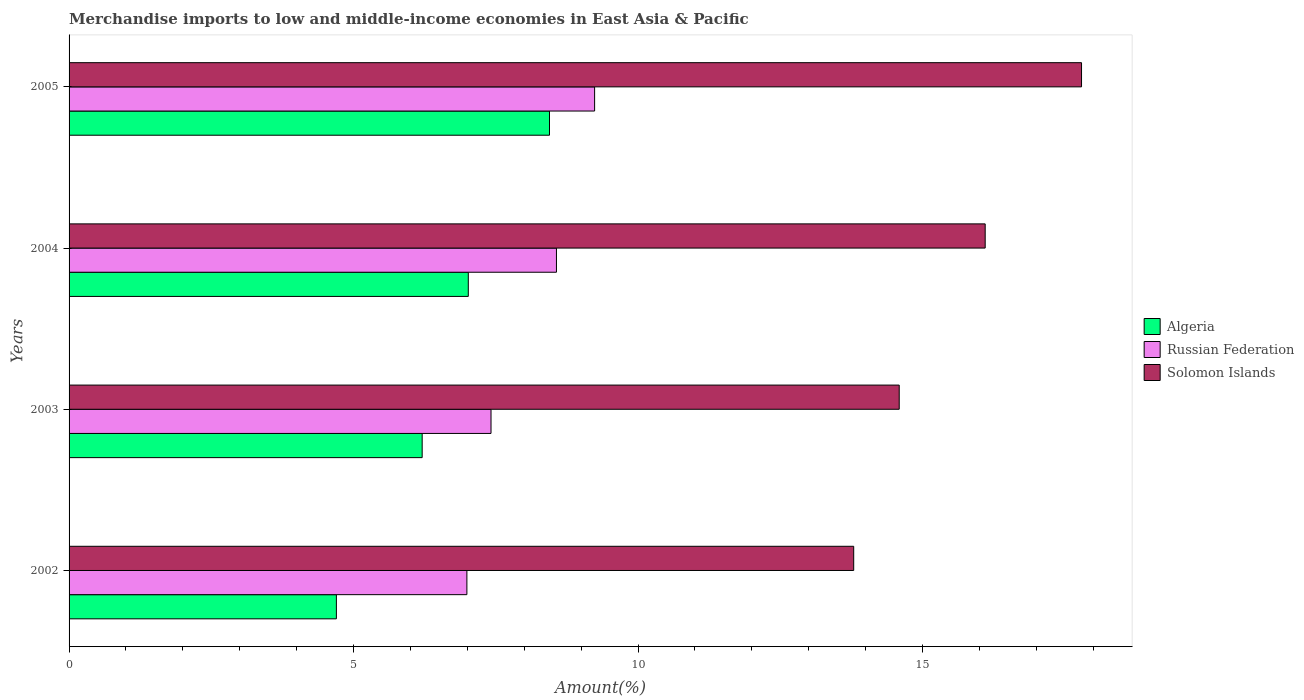Are the number of bars on each tick of the Y-axis equal?
Your answer should be very brief. Yes. How many bars are there on the 2nd tick from the top?
Your answer should be very brief. 3. What is the label of the 1st group of bars from the top?
Your answer should be compact. 2005. What is the percentage of amount earned from merchandise imports in Algeria in 2002?
Your answer should be very brief. 4.7. Across all years, what is the maximum percentage of amount earned from merchandise imports in Solomon Islands?
Your answer should be compact. 17.79. Across all years, what is the minimum percentage of amount earned from merchandise imports in Solomon Islands?
Keep it short and to the point. 13.79. In which year was the percentage of amount earned from merchandise imports in Russian Federation maximum?
Your answer should be compact. 2005. In which year was the percentage of amount earned from merchandise imports in Russian Federation minimum?
Your answer should be very brief. 2002. What is the total percentage of amount earned from merchandise imports in Algeria in the graph?
Provide a succinct answer. 26.36. What is the difference between the percentage of amount earned from merchandise imports in Russian Federation in 2003 and that in 2004?
Your answer should be very brief. -1.15. What is the difference between the percentage of amount earned from merchandise imports in Russian Federation in 2004 and the percentage of amount earned from merchandise imports in Solomon Islands in 2003?
Offer a very short reply. -6.02. What is the average percentage of amount earned from merchandise imports in Algeria per year?
Keep it short and to the point. 6.59. In the year 2003, what is the difference between the percentage of amount earned from merchandise imports in Solomon Islands and percentage of amount earned from merchandise imports in Russian Federation?
Offer a very short reply. 7.17. In how many years, is the percentage of amount earned from merchandise imports in Algeria greater than 8 %?
Keep it short and to the point. 1. What is the ratio of the percentage of amount earned from merchandise imports in Russian Federation in 2002 to that in 2005?
Ensure brevity in your answer.  0.76. What is the difference between the highest and the second highest percentage of amount earned from merchandise imports in Russian Federation?
Keep it short and to the point. 0.67. What is the difference between the highest and the lowest percentage of amount earned from merchandise imports in Algeria?
Ensure brevity in your answer.  3.75. In how many years, is the percentage of amount earned from merchandise imports in Algeria greater than the average percentage of amount earned from merchandise imports in Algeria taken over all years?
Make the answer very short. 2. What does the 3rd bar from the top in 2002 represents?
Your answer should be compact. Algeria. What does the 1st bar from the bottom in 2005 represents?
Your answer should be very brief. Algeria. Is it the case that in every year, the sum of the percentage of amount earned from merchandise imports in Solomon Islands and percentage of amount earned from merchandise imports in Russian Federation is greater than the percentage of amount earned from merchandise imports in Algeria?
Offer a very short reply. Yes. How many bars are there?
Your response must be concise. 12. Are all the bars in the graph horizontal?
Your answer should be very brief. Yes. What is the difference between two consecutive major ticks on the X-axis?
Your response must be concise. 5. Are the values on the major ticks of X-axis written in scientific E-notation?
Your answer should be compact. No. Does the graph contain any zero values?
Provide a short and direct response. No. How are the legend labels stacked?
Your answer should be compact. Vertical. What is the title of the graph?
Your answer should be very brief. Merchandise imports to low and middle-income economies in East Asia & Pacific. What is the label or title of the X-axis?
Your answer should be very brief. Amount(%). What is the Amount(%) of Algeria in 2002?
Your answer should be very brief. 4.7. What is the Amount(%) of Russian Federation in 2002?
Give a very brief answer. 6.99. What is the Amount(%) in Solomon Islands in 2002?
Your answer should be very brief. 13.79. What is the Amount(%) of Algeria in 2003?
Keep it short and to the point. 6.21. What is the Amount(%) of Russian Federation in 2003?
Your response must be concise. 7.42. What is the Amount(%) in Solomon Islands in 2003?
Provide a succinct answer. 14.59. What is the Amount(%) of Algeria in 2004?
Your answer should be compact. 7.02. What is the Amount(%) in Russian Federation in 2004?
Ensure brevity in your answer.  8.57. What is the Amount(%) in Solomon Islands in 2004?
Provide a short and direct response. 16.1. What is the Amount(%) of Algeria in 2005?
Your answer should be compact. 8.44. What is the Amount(%) of Russian Federation in 2005?
Your answer should be compact. 9.24. What is the Amount(%) of Solomon Islands in 2005?
Provide a short and direct response. 17.79. Across all years, what is the maximum Amount(%) of Algeria?
Your answer should be compact. 8.44. Across all years, what is the maximum Amount(%) of Russian Federation?
Offer a terse response. 9.24. Across all years, what is the maximum Amount(%) of Solomon Islands?
Give a very brief answer. 17.79. Across all years, what is the minimum Amount(%) in Algeria?
Ensure brevity in your answer.  4.7. Across all years, what is the minimum Amount(%) of Russian Federation?
Make the answer very short. 6.99. Across all years, what is the minimum Amount(%) of Solomon Islands?
Keep it short and to the point. 13.79. What is the total Amount(%) in Algeria in the graph?
Ensure brevity in your answer.  26.36. What is the total Amount(%) in Russian Federation in the graph?
Ensure brevity in your answer.  32.21. What is the total Amount(%) of Solomon Islands in the graph?
Your response must be concise. 62.28. What is the difference between the Amount(%) in Algeria in 2002 and that in 2003?
Provide a succinct answer. -1.51. What is the difference between the Amount(%) in Russian Federation in 2002 and that in 2003?
Provide a succinct answer. -0.42. What is the difference between the Amount(%) in Solomon Islands in 2002 and that in 2003?
Give a very brief answer. -0.8. What is the difference between the Amount(%) in Algeria in 2002 and that in 2004?
Your response must be concise. -2.32. What is the difference between the Amount(%) in Russian Federation in 2002 and that in 2004?
Make the answer very short. -1.57. What is the difference between the Amount(%) of Solomon Islands in 2002 and that in 2004?
Provide a succinct answer. -2.31. What is the difference between the Amount(%) in Algeria in 2002 and that in 2005?
Your response must be concise. -3.75. What is the difference between the Amount(%) in Russian Federation in 2002 and that in 2005?
Make the answer very short. -2.24. What is the difference between the Amount(%) of Solomon Islands in 2002 and that in 2005?
Provide a short and direct response. -4. What is the difference between the Amount(%) of Algeria in 2003 and that in 2004?
Your answer should be compact. -0.81. What is the difference between the Amount(%) in Russian Federation in 2003 and that in 2004?
Your response must be concise. -1.15. What is the difference between the Amount(%) of Solomon Islands in 2003 and that in 2004?
Your answer should be very brief. -1.51. What is the difference between the Amount(%) of Algeria in 2003 and that in 2005?
Ensure brevity in your answer.  -2.24. What is the difference between the Amount(%) of Russian Federation in 2003 and that in 2005?
Ensure brevity in your answer.  -1.82. What is the difference between the Amount(%) of Solomon Islands in 2003 and that in 2005?
Make the answer very short. -3.2. What is the difference between the Amount(%) of Algeria in 2004 and that in 2005?
Offer a very short reply. -1.43. What is the difference between the Amount(%) in Russian Federation in 2004 and that in 2005?
Your answer should be very brief. -0.67. What is the difference between the Amount(%) in Solomon Islands in 2004 and that in 2005?
Your answer should be very brief. -1.69. What is the difference between the Amount(%) in Algeria in 2002 and the Amount(%) in Russian Federation in 2003?
Your response must be concise. -2.72. What is the difference between the Amount(%) of Algeria in 2002 and the Amount(%) of Solomon Islands in 2003?
Offer a very short reply. -9.89. What is the difference between the Amount(%) of Russian Federation in 2002 and the Amount(%) of Solomon Islands in 2003?
Your answer should be very brief. -7.6. What is the difference between the Amount(%) of Algeria in 2002 and the Amount(%) of Russian Federation in 2004?
Offer a terse response. -3.87. What is the difference between the Amount(%) in Algeria in 2002 and the Amount(%) in Solomon Islands in 2004?
Make the answer very short. -11.4. What is the difference between the Amount(%) in Russian Federation in 2002 and the Amount(%) in Solomon Islands in 2004?
Ensure brevity in your answer.  -9.11. What is the difference between the Amount(%) of Algeria in 2002 and the Amount(%) of Russian Federation in 2005?
Make the answer very short. -4.54. What is the difference between the Amount(%) in Algeria in 2002 and the Amount(%) in Solomon Islands in 2005?
Your response must be concise. -13.1. What is the difference between the Amount(%) in Russian Federation in 2002 and the Amount(%) in Solomon Islands in 2005?
Your response must be concise. -10.8. What is the difference between the Amount(%) in Algeria in 2003 and the Amount(%) in Russian Federation in 2004?
Provide a succinct answer. -2.36. What is the difference between the Amount(%) of Algeria in 2003 and the Amount(%) of Solomon Islands in 2004?
Your answer should be very brief. -9.9. What is the difference between the Amount(%) of Russian Federation in 2003 and the Amount(%) of Solomon Islands in 2004?
Your answer should be very brief. -8.69. What is the difference between the Amount(%) of Algeria in 2003 and the Amount(%) of Russian Federation in 2005?
Offer a terse response. -3.03. What is the difference between the Amount(%) in Algeria in 2003 and the Amount(%) in Solomon Islands in 2005?
Make the answer very short. -11.59. What is the difference between the Amount(%) in Russian Federation in 2003 and the Amount(%) in Solomon Islands in 2005?
Give a very brief answer. -10.38. What is the difference between the Amount(%) of Algeria in 2004 and the Amount(%) of Russian Federation in 2005?
Ensure brevity in your answer.  -2.22. What is the difference between the Amount(%) in Algeria in 2004 and the Amount(%) in Solomon Islands in 2005?
Your answer should be compact. -10.78. What is the difference between the Amount(%) in Russian Federation in 2004 and the Amount(%) in Solomon Islands in 2005?
Provide a short and direct response. -9.23. What is the average Amount(%) in Algeria per year?
Offer a terse response. 6.59. What is the average Amount(%) of Russian Federation per year?
Your answer should be compact. 8.05. What is the average Amount(%) of Solomon Islands per year?
Keep it short and to the point. 15.57. In the year 2002, what is the difference between the Amount(%) of Algeria and Amount(%) of Russian Federation?
Provide a succinct answer. -2.29. In the year 2002, what is the difference between the Amount(%) of Algeria and Amount(%) of Solomon Islands?
Make the answer very short. -9.09. In the year 2002, what is the difference between the Amount(%) of Russian Federation and Amount(%) of Solomon Islands?
Offer a terse response. -6.8. In the year 2003, what is the difference between the Amount(%) in Algeria and Amount(%) in Russian Federation?
Provide a short and direct response. -1.21. In the year 2003, what is the difference between the Amount(%) in Algeria and Amount(%) in Solomon Islands?
Ensure brevity in your answer.  -8.38. In the year 2003, what is the difference between the Amount(%) in Russian Federation and Amount(%) in Solomon Islands?
Offer a very short reply. -7.17. In the year 2004, what is the difference between the Amount(%) of Algeria and Amount(%) of Russian Federation?
Make the answer very short. -1.55. In the year 2004, what is the difference between the Amount(%) in Algeria and Amount(%) in Solomon Islands?
Your answer should be very brief. -9.08. In the year 2004, what is the difference between the Amount(%) in Russian Federation and Amount(%) in Solomon Islands?
Your answer should be compact. -7.54. In the year 2005, what is the difference between the Amount(%) in Algeria and Amount(%) in Russian Federation?
Make the answer very short. -0.79. In the year 2005, what is the difference between the Amount(%) in Algeria and Amount(%) in Solomon Islands?
Keep it short and to the point. -9.35. In the year 2005, what is the difference between the Amount(%) of Russian Federation and Amount(%) of Solomon Islands?
Offer a terse response. -8.56. What is the ratio of the Amount(%) in Algeria in 2002 to that in 2003?
Make the answer very short. 0.76. What is the ratio of the Amount(%) in Russian Federation in 2002 to that in 2003?
Provide a succinct answer. 0.94. What is the ratio of the Amount(%) in Solomon Islands in 2002 to that in 2003?
Give a very brief answer. 0.95. What is the ratio of the Amount(%) in Algeria in 2002 to that in 2004?
Ensure brevity in your answer.  0.67. What is the ratio of the Amount(%) of Russian Federation in 2002 to that in 2004?
Offer a very short reply. 0.82. What is the ratio of the Amount(%) in Solomon Islands in 2002 to that in 2004?
Make the answer very short. 0.86. What is the ratio of the Amount(%) of Algeria in 2002 to that in 2005?
Provide a succinct answer. 0.56. What is the ratio of the Amount(%) of Russian Federation in 2002 to that in 2005?
Offer a very short reply. 0.76. What is the ratio of the Amount(%) in Solomon Islands in 2002 to that in 2005?
Your answer should be very brief. 0.78. What is the ratio of the Amount(%) in Algeria in 2003 to that in 2004?
Your answer should be very brief. 0.88. What is the ratio of the Amount(%) in Russian Federation in 2003 to that in 2004?
Your response must be concise. 0.87. What is the ratio of the Amount(%) of Solomon Islands in 2003 to that in 2004?
Ensure brevity in your answer.  0.91. What is the ratio of the Amount(%) in Algeria in 2003 to that in 2005?
Your answer should be compact. 0.73. What is the ratio of the Amount(%) in Russian Federation in 2003 to that in 2005?
Provide a succinct answer. 0.8. What is the ratio of the Amount(%) in Solomon Islands in 2003 to that in 2005?
Provide a short and direct response. 0.82. What is the ratio of the Amount(%) of Algeria in 2004 to that in 2005?
Ensure brevity in your answer.  0.83. What is the ratio of the Amount(%) in Russian Federation in 2004 to that in 2005?
Your answer should be very brief. 0.93. What is the ratio of the Amount(%) of Solomon Islands in 2004 to that in 2005?
Offer a terse response. 0.9. What is the difference between the highest and the second highest Amount(%) in Algeria?
Provide a short and direct response. 1.43. What is the difference between the highest and the second highest Amount(%) in Russian Federation?
Provide a succinct answer. 0.67. What is the difference between the highest and the second highest Amount(%) of Solomon Islands?
Your response must be concise. 1.69. What is the difference between the highest and the lowest Amount(%) of Algeria?
Your answer should be very brief. 3.75. What is the difference between the highest and the lowest Amount(%) of Russian Federation?
Your answer should be compact. 2.24. What is the difference between the highest and the lowest Amount(%) in Solomon Islands?
Ensure brevity in your answer.  4. 